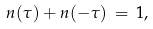Convert formula to latex. <formula><loc_0><loc_0><loc_500><loc_500>n ( \tau ) + n ( - \tau ) \, = \, 1 ,</formula> 